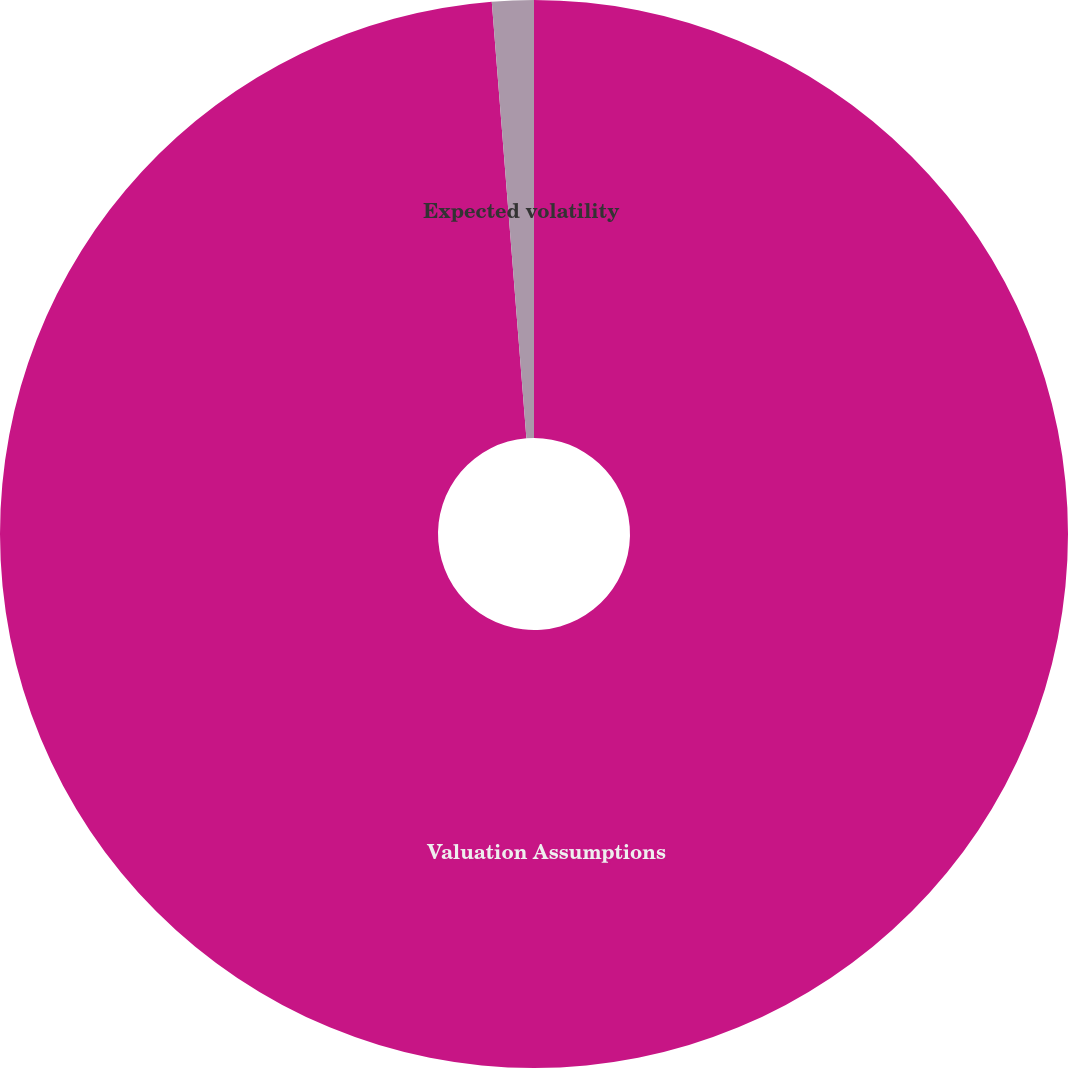Convert chart. <chart><loc_0><loc_0><loc_500><loc_500><pie_chart><fcel>Valuation Assumptions<fcel>Expected volatility<nl><fcel>98.74%<fcel>1.26%<nl></chart> 